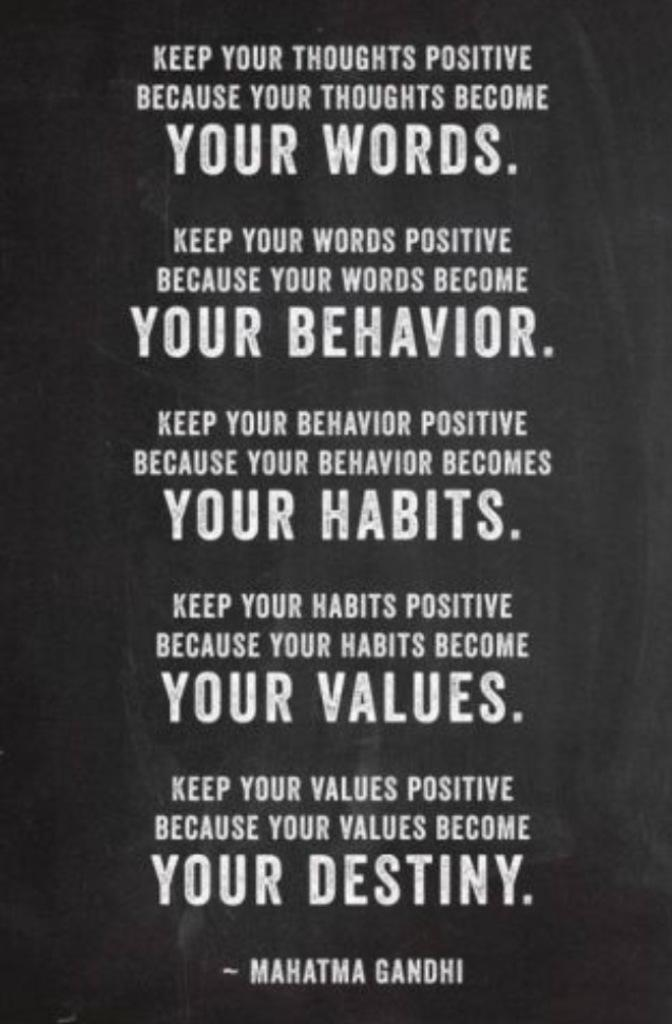<image>
Write a terse but informative summary of the picture. A poster of a quote that starts with "Keep your thoughts positive because your thoughts become your words." 